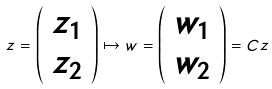Convert formula to latex. <formula><loc_0><loc_0><loc_500><loc_500>z = \left ( \begin{array} { c } z _ { 1 } \\ z _ { 2 } \end{array} \right ) \mapsto w = \left ( \begin{array} { c } w _ { 1 } \\ w _ { 2 } \end{array} \right ) = C z</formula> 